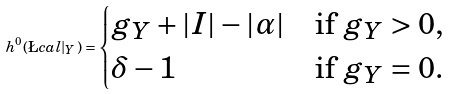Convert formula to latex. <formula><loc_0><loc_0><loc_500><loc_500>h ^ { 0 } ( \L c a l | _ { Y } ) = \begin{cases} g _ { Y } + | I | - | \alpha | & \text {if $g_{Y}>0$,} \\ \delta - 1 & \text {if $g_{Y}=0$.} \end{cases}</formula> 